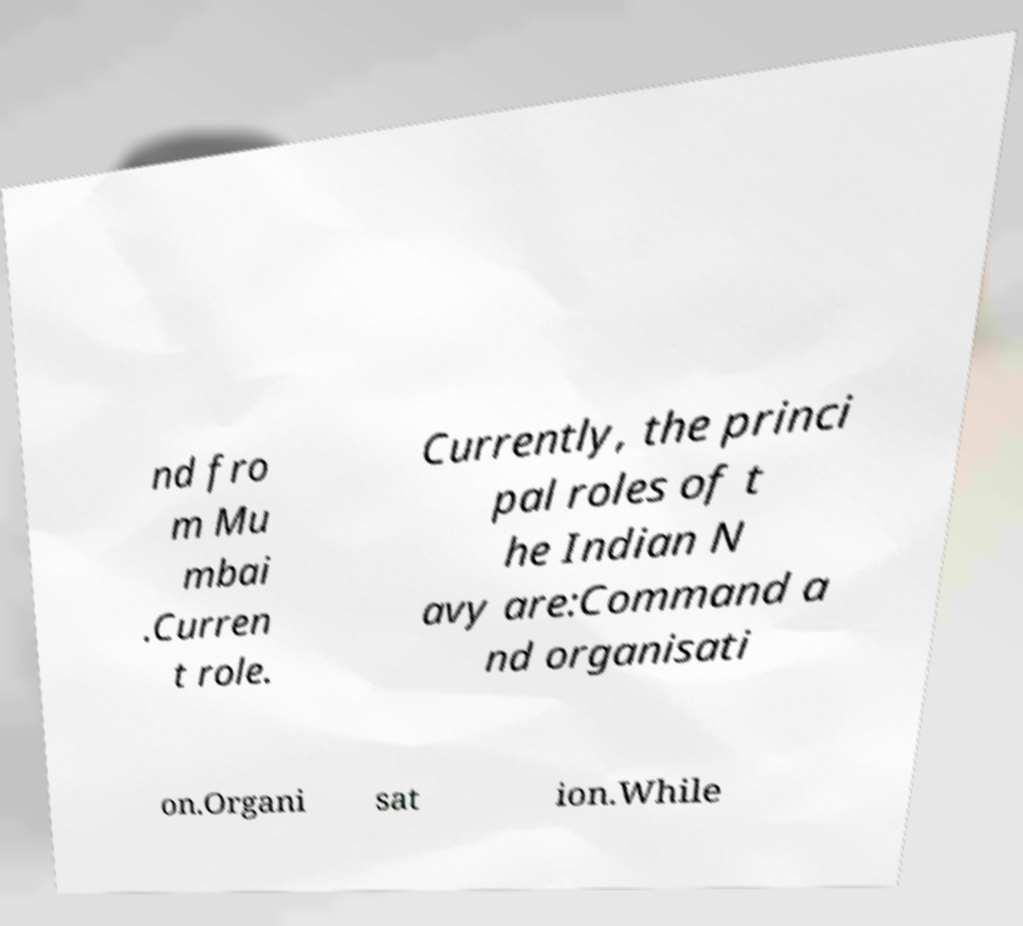Could you extract and type out the text from this image? nd fro m Mu mbai .Curren t role. Currently, the princi pal roles of t he Indian N avy are:Command a nd organisati on.Organi sat ion.While 